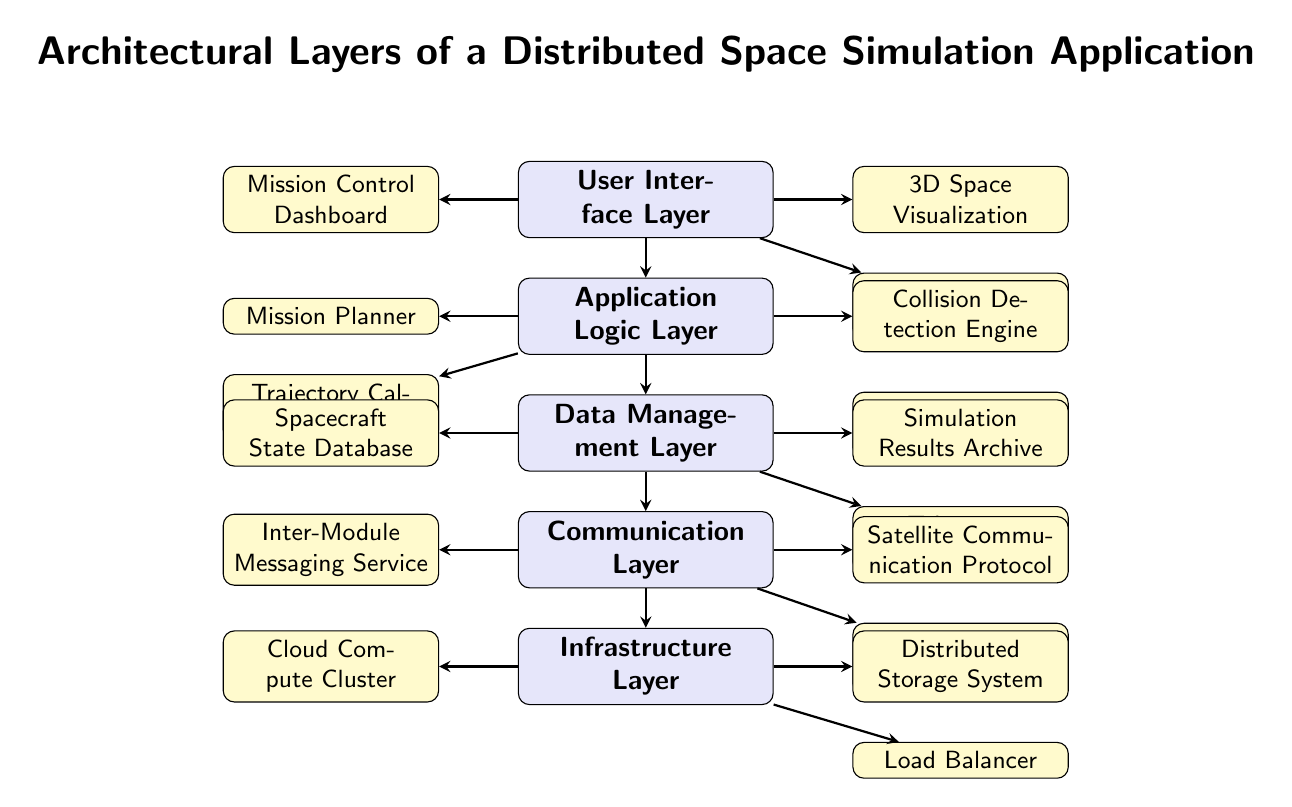what are the names of the top two layers? The top two layers of the diagram are the User Interface Layer and the Application Logic Layer.
Answer: User Interface Layer, Application Logic Layer how many components are there in the Communication Layer? The Communication Layer has three components: Inter-Module Messaging Service, Satellite Communication Protocol, and Network Bandwidth Manager.
Answer: 3 which layer is directly above the Data Management Layer? The layer directly above the Data Management Layer is the Application Logic Layer.
Answer: Application Logic Layer what component is found in the Application Logic Layer associated with trajectory? The component in the Application Logic Layer associated with trajectory is the Trajectory Calculation Service.
Answer: Trajectory Calculation Service how many layers are there in total? There are five layers listed in the diagram: User Interface Layer, Application Logic Layer, Data Management Layer, Communication Layer, and Infrastructure Layer.
Answer: 5 which component in the Infrastructure Layer deals with load distribution? The component in the Infrastructure Layer that deals with load distribution is the Load Balancer.
Answer: Load Balancer what is the role of the component named Collision Detection Engine? The Collision Detection Engine is a component in the Application Logic Layer that is responsible for detecting potential collisions during space simulation.
Answer: Detecting collisions identify the layer that manages data storage and archives. The layer that manages data storage and archives is the Data Management Layer.
Answer: Data Management Layer which component in the User Interface Layer corresponds to the visual representation of space? The component that corresponds to the visual representation of space in the User Interface Layer is the 3D Space Visualization.
Answer: 3D Space Visualization 